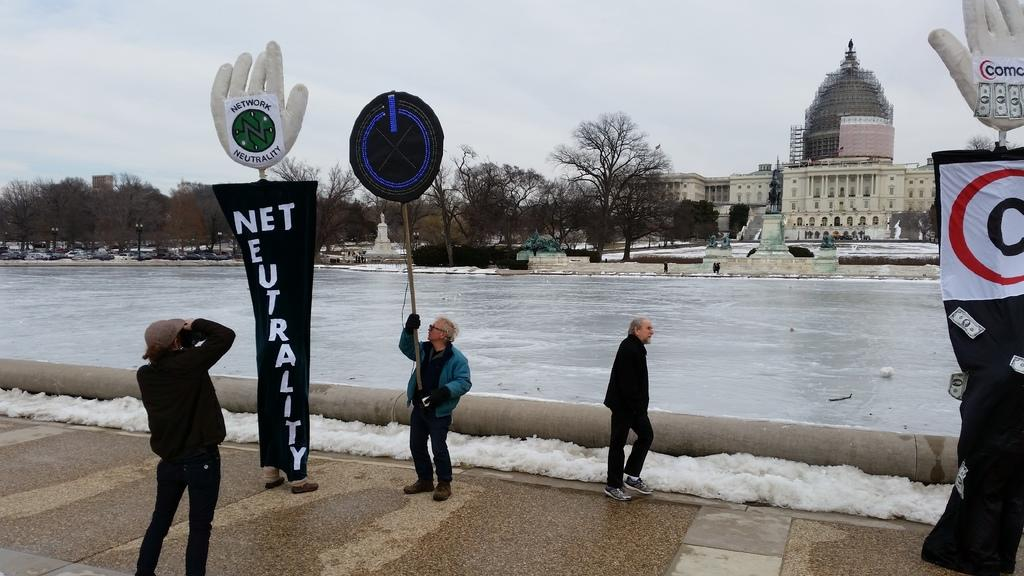<image>
Relay a brief, clear account of the picture shown. A person taking a picture of a man holding up a sign next to a sign that says Net Neutrality 